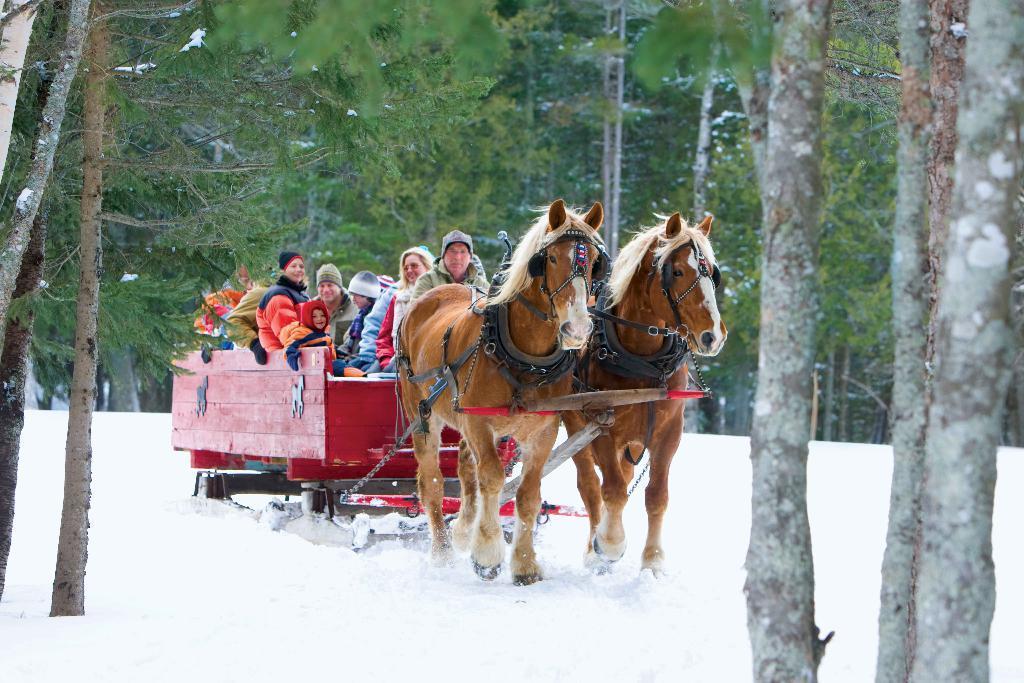Describe this image in one or two sentences. In this image in the center there are group of persons sitting in a cart which is carried by the horses. In the background there are trees and in the front there is snow on the ground. 